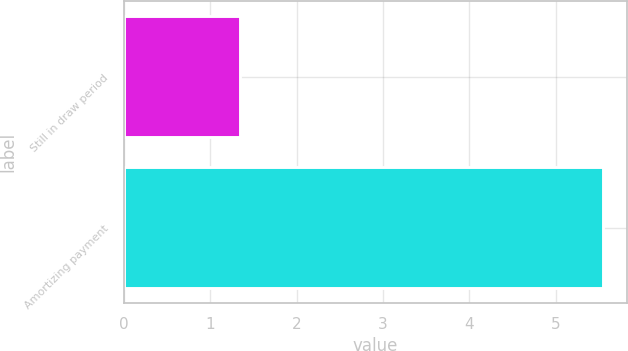Convert chart. <chart><loc_0><loc_0><loc_500><loc_500><bar_chart><fcel>Still in draw period<fcel>Amortizing payment<nl><fcel>1.35<fcel>5.55<nl></chart> 